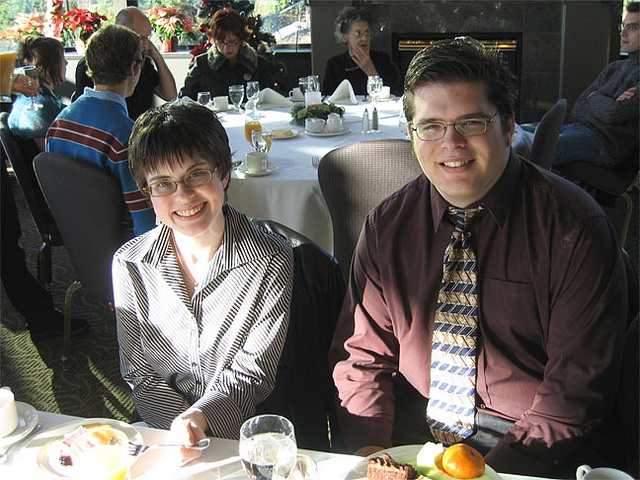Describe the objects in this image and their specific colors. I can see people in darkgray, black, and gray tones, people in darkgray, white, black, and gray tones, dining table in darkgray, white, beige, and black tones, dining table in darkgray, white, and gray tones, and chair in darkgray, black, white, and gray tones in this image. 